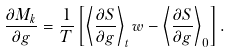<formula> <loc_0><loc_0><loc_500><loc_500>\frac { \partial M _ { k } } { \partial g } = \frac { 1 } { T } \left [ \left < \frac { \partial S } { \partial g } \right > _ { t } w - \left < \frac { \partial S } { \partial g } \right > _ { 0 } \right ] .</formula> 